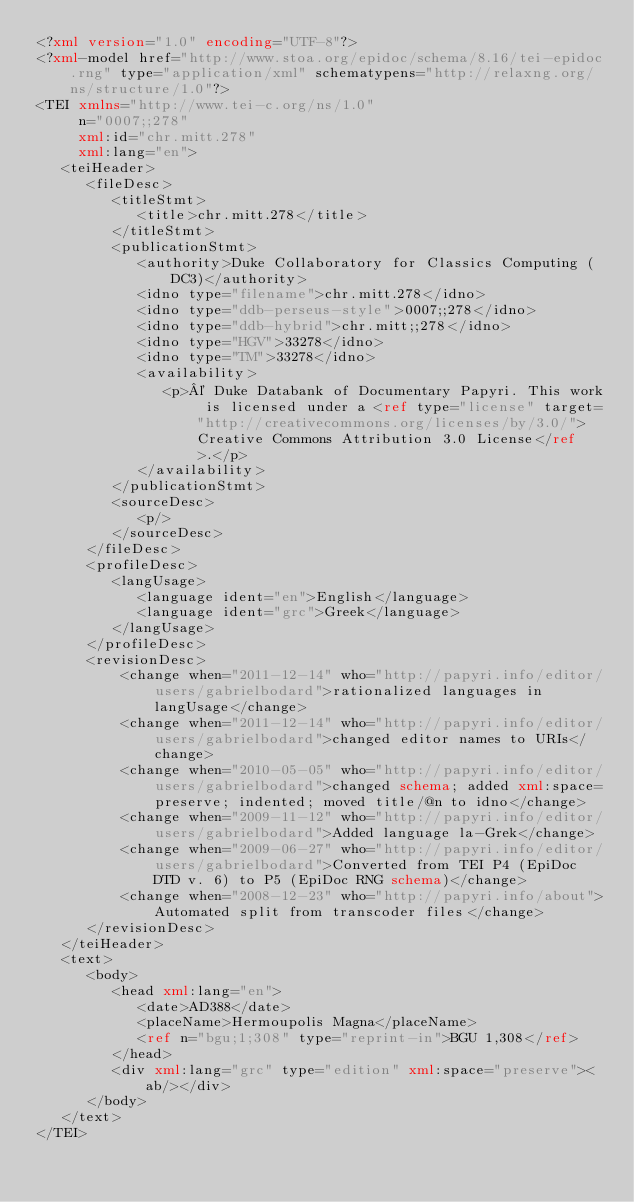<code> <loc_0><loc_0><loc_500><loc_500><_XML_><?xml version="1.0" encoding="UTF-8"?>
<?xml-model href="http://www.stoa.org/epidoc/schema/8.16/tei-epidoc.rng" type="application/xml" schematypens="http://relaxng.org/ns/structure/1.0"?>
<TEI xmlns="http://www.tei-c.org/ns/1.0"
     n="0007;;278"
     xml:id="chr.mitt.278"
     xml:lang="en">
   <teiHeader>
      <fileDesc>
         <titleStmt>
            <title>chr.mitt.278</title>
         </titleStmt>
         <publicationStmt>
            <authority>Duke Collaboratory for Classics Computing (DC3)</authority>
            <idno type="filename">chr.mitt.278</idno>
            <idno type="ddb-perseus-style">0007;;278</idno>
            <idno type="ddb-hybrid">chr.mitt;;278</idno>
            <idno type="HGV">33278</idno>
            <idno type="TM">33278</idno>
            <availability>
               <p>© Duke Databank of Documentary Papyri. This work is licensed under a <ref type="license" target="http://creativecommons.org/licenses/by/3.0/">Creative Commons Attribution 3.0 License</ref>.</p>
            </availability>
         </publicationStmt>
         <sourceDesc>
            <p/>
         </sourceDesc>
      </fileDesc>
      <profileDesc>
         <langUsage>
            <language ident="en">English</language>
            <language ident="grc">Greek</language>
         </langUsage>
      </profileDesc>
      <revisionDesc>
          <change when="2011-12-14" who="http://papyri.info/editor/users/gabrielbodard">rationalized languages in langUsage</change>
          <change when="2011-12-14" who="http://papyri.info/editor/users/gabrielbodard">changed editor names to URIs</change>
          <change when="2010-05-05" who="http://papyri.info/editor/users/gabrielbodard">changed schema; added xml:space=preserve; indented; moved title/@n to idno</change>
          <change when="2009-11-12" who="http://papyri.info/editor/users/gabrielbodard">Added language la-Grek</change>
          <change when="2009-06-27" who="http://papyri.info/editor/users/gabrielbodard">Converted from TEI P4 (EpiDoc DTD v. 6) to P5 (EpiDoc RNG schema)</change>
          <change when="2008-12-23" who="http://papyri.info/about">Automated split from transcoder files</change>
      </revisionDesc>
   </teiHeader>
   <text>
      <body>
         <head xml:lang="en">
            <date>AD388</date>
            <placeName>Hermoupolis Magna</placeName>
            <ref n="bgu;1;308" type="reprint-in">BGU 1,308</ref>
         </head>
         <div xml:lang="grc" type="edition" xml:space="preserve"><ab/></div>
      </body>
   </text>
</TEI>
</code> 